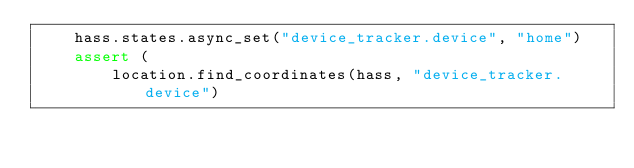Convert code to text. <code><loc_0><loc_0><loc_500><loc_500><_Python_>    hass.states.async_set("device_tracker.device", "home")
    assert (
        location.find_coordinates(hass, "device_tracker.device")</code> 